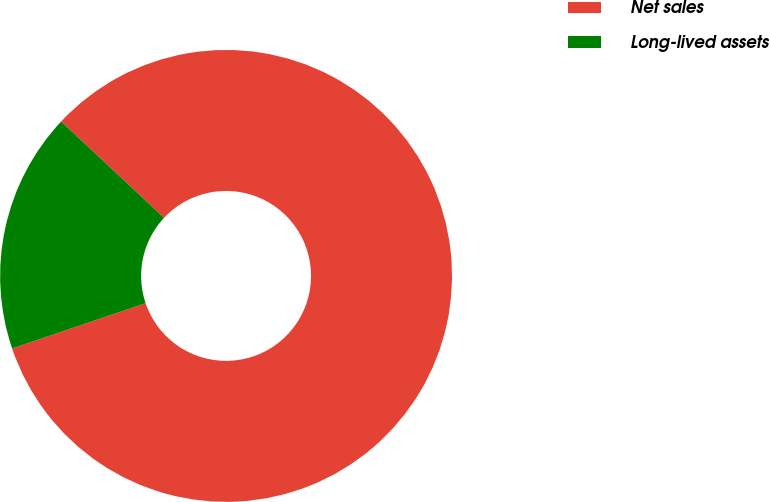Convert chart to OTSL. <chart><loc_0><loc_0><loc_500><loc_500><pie_chart><fcel>Net sales<fcel>Long-lived assets<nl><fcel>82.82%<fcel>17.18%<nl></chart> 